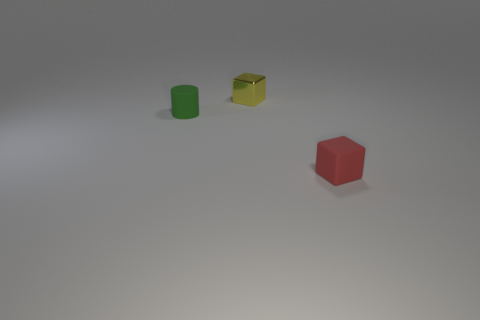How many small green matte cylinders are in front of the tiny cube that is to the left of the red cube? 1 